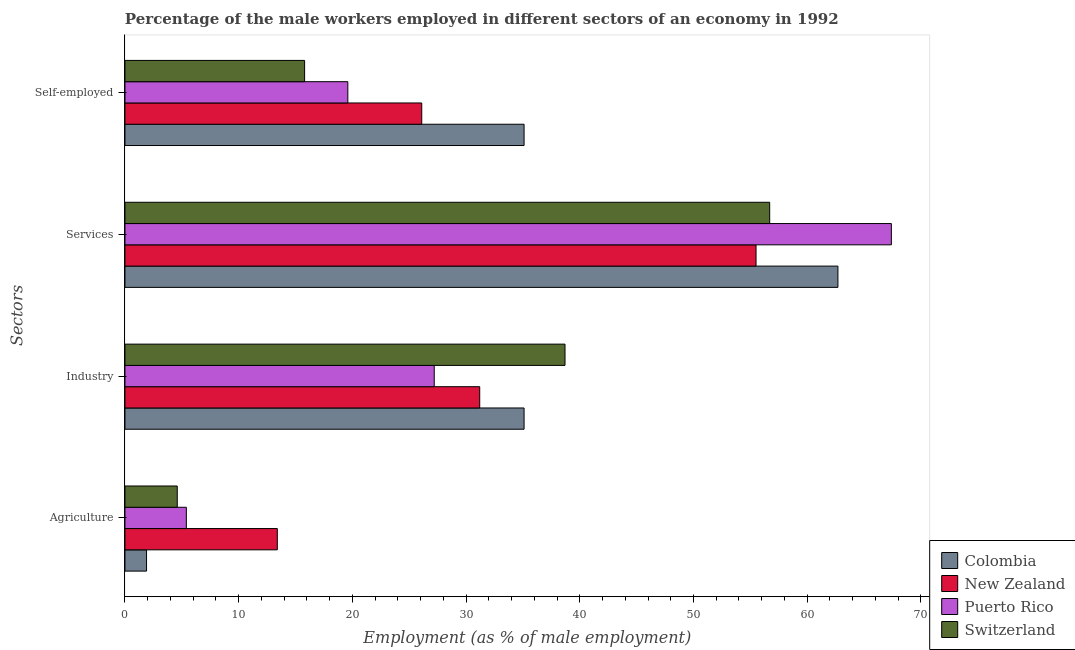How many groups of bars are there?
Give a very brief answer. 4. Are the number of bars per tick equal to the number of legend labels?
Offer a terse response. Yes. Are the number of bars on each tick of the Y-axis equal?
Make the answer very short. Yes. How many bars are there on the 1st tick from the top?
Make the answer very short. 4. How many bars are there on the 1st tick from the bottom?
Keep it short and to the point. 4. What is the label of the 3rd group of bars from the top?
Your response must be concise. Industry. What is the percentage of male workers in industry in Puerto Rico?
Offer a terse response. 27.2. Across all countries, what is the maximum percentage of self employed male workers?
Your answer should be compact. 35.1. Across all countries, what is the minimum percentage of male workers in industry?
Provide a succinct answer. 27.2. In which country was the percentage of self employed male workers maximum?
Make the answer very short. Colombia. In which country was the percentage of male workers in services minimum?
Offer a very short reply. New Zealand. What is the total percentage of male workers in services in the graph?
Give a very brief answer. 242.3. What is the difference between the percentage of male workers in agriculture in Switzerland and that in New Zealand?
Offer a terse response. -8.8. What is the difference between the percentage of male workers in agriculture in New Zealand and the percentage of male workers in services in Colombia?
Offer a very short reply. -49.3. What is the average percentage of male workers in services per country?
Your response must be concise. 60.58. What is the difference between the percentage of male workers in industry and percentage of male workers in services in Colombia?
Your answer should be very brief. -27.6. What is the ratio of the percentage of male workers in industry in Colombia to that in New Zealand?
Give a very brief answer. 1.12. Is the percentage of male workers in agriculture in Switzerland less than that in Puerto Rico?
Provide a succinct answer. Yes. Is the difference between the percentage of male workers in industry in Switzerland and Colombia greater than the difference between the percentage of male workers in agriculture in Switzerland and Colombia?
Offer a terse response. Yes. What is the difference between the highest and the second highest percentage of male workers in industry?
Provide a short and direct response. 3.6. What is the difference between the highest and the lowest percentage of self employed male workers?
Offer a terse response. 19.3. In how many countries, is the percentage of male workers in agriculture greater than the average percentage of male workers in agriculture taken over all countries?
Offer a terse response. 1. Is the sum of the percentage of self employed male workers in Colombia and New Zealand greater than the maximum percentage of male workers in industry across all countries?
Keep it short and to the point. Yes. What does the 1st bar from the top in Agriculture represents?
Offer a terse response. Switzerland. What does the 3rd bar from the bottom in Industry represents?
Provide a succinct answer. Puerto Rico. Is it the case that in every country, the sum of the percentage of male workers in agriculture and percentage of male workers in industry is greater than the percentage of male workers in services?
Ensure brevity in your answer.  No. Are the values on the major ticks of X-axis written in scientific E-notation?
Your answer should be very brief. No. Where does the legend appear in the graph?
Provide a succinct answer. Bottom right. How many legend labels are there?
Make the answer very short. 4. What is the title of the graph?
Provide a succinct answer. Percentage of the male workers employed in different sectors of an economy in 1992. Does "Brunei Darussalam" appear as one of the legend labels in the graph?
Give a very brief answer. No. What is the label or title of the X-axis?
Provide a short and direct response. Employment (as % of male employment). What is the label or title of the Y-axis?
Offer a terse response. Sectors. What is the Employment (as % of male employment) of Colombia in Agriculture?
Keep it short and to the point. 1.9. What is the Employment (as % of male employment) of New Zealand in Agriculture?
Ensure brevity in your answer.  13.4. What is the Employment (as % of male employment) in Puerto Rico in Agriculture?
Provide a succinct answer. 5.4. What is the Employment (as % of male employment) of Switzerland in Agriculture?
Your answer should be very brief. 4.6. What is the Employment (as % of male employment) in Colombia in Industry?
Your response must be concise. 35.1. What is the Employment (as % of male employment) of New Zealand in Industry?
Offer a very short reply. 31.2. What is the Employment (as % of male employment) of Puerto Rico in Industry?
Provide a succinct answer. 27.2. What is the Employment (as % of male employment) of Switzerland in Industry?
Ensure brevity in your answer.  38.7. What is the Employment (as % of male employment) of Colombia in Services?
Your response must be concise. 62.7. What is the Employment (as % of male employment) in New Zealand in Services?
Give a very brief answer. 55.5. What is the Employment (as % of male employment) of Puerto Rico in Services?
Your answer should be compact. 67.4. What is the Employment (as % of male employment) in Switzerland in Services?
Make the answer very short. 56.7. What is the Employment (as % of male employment) in Colombia in Self-employed?
Offer a very short reply. 35.1. What is the Employment (as % of male employment) in New Zealand in Self-employed?
Give a very brief answer. 26.1. What is the Employment (as % of male employment) in Puerto Rico in Self-employed?
Keep it short and to the point. 19.6. What is the Employment (as % of male employment) of Switzerland in Self-employed?
Provide a short and direct response. 15.8. Across all Sectors, what is the maximum Employment (as % of male employment) of Colombia?
Give a very brief answer. 62.7. Across all Sectors, what is the maximum Employment (as % of male employment) in New Zealand?
Keep it short and to the point. 55.5. Across all Sectors, what is the maximum Employment (as % of male employment) of Puerto Rico?
Offer a very short reply. 67.4. Across all Sectors, what is the maximum Employment (as % of male employment) of Switzerland?
Offer a terse response. 56.7. Across all Sectors, what is the minimum Employment (as % of male employment) of Colombia?
Make the answer very short. 1.9. Across all Sectors, what is the minimum Employment (as % of male employment) of New Zealand?
Offer a very short reply. 13.4. Across all Sectors, what is the minimum Employment (as % of male employment) of Puerto Rico?
Keep it short and to the point. 5.4. Across all Sectors, what is the minimum Employment (as % of male employment) of Switzerland?
Your response must be concise. 4.6. What is the total Employment (as % of male employment) of Colombia in the graph?
Ensure brevity in your answer.  134.8. What is the total Employment (as % of male employment) of New Zealand in the graph?
Make the answer very short. 126.2. What is the total Employment (as % of male employment) of Puerto Rico in the graph?
Provide a succinct answer. 119.6. What is the total Employment (as % of male employment) of Switzerland in the graph?
Your answer should be very brief. 115.8. What is the difference between the Employment (as % of male employment) in Colombia in Agriculture and that in Industry?
Your response must be concise. -33.2. What is the difference between the Employment (as % of male employment) of New Zealand in Agriculture and that in Industry?
Keep it short and to the point. -17.8. What is the difference between the Employment (as % of male employment) in Puerto Rico in Agriculture and that in Industry?
Offer a very short reply. -21.8. What is the difference between the Employment (as % of male employment) in Switzerland in Agriculture and that in Industry?
Provide a short and direct response. -34.1. What is the difference between the Employment (as % of male employment) in Colombia in Agriculture and that in Services?
Your response must be concise. -60.8. What is the difference between the Employment (as % of male employment) in New Zealand in Agriculture and that in Services?
Provide a short and direct response. -42.1. What is the difference between the Employment (as % of male employment) in Puerto Rico in Agriculture and that in Services?
Make the answer very short. -62. What is the difference between the Employment (as % of male employment) in Switzerland in Agriculture and that in Services?
Keep it short and to the point. -52.1. What is the difference between the Employment (as % of male employment) of Colombia in Agriculture and that in Self-employed?
Offer a very short reply. -33.2. What is the difference between the Employment (as % of male employment) of Colombia in Industry and that in Services?
Your answer should be compact. -27.6. What is the difference between the Employment (as % of male employment) of New Zealand in Industry and that in Services?
Your answer should be very brief. -24.3. What is the difference between the Employment (as % of male employment) in Puerto Rico in Industry and that in Services?
Your answer should be compact. -40.2. What is the difference between the Employment (as % of male employment) of Switzerland in Industry and that in Services?
Your response must be concise. -18. What is the difference between the Employment (as % of male employment) of Colombia in Industry and that in Self-employed?
Ensure brevity in your answer.  0. What is the difference between the Employment (as % of male employment) of Switzerland in Industry and that in Self-employed?
Provide a short and direct response. 22.9. What is the difference between the Employment (as % of male employment) of Colombia in Services and that in Self-employed?
Your answer should be very brief. 27.6. What is the difference between the Employment (as % of male employment) in New Zealand in Services and that in Self-employed?
Give a very brief answer. 29.4. What is the difference between the Employment (as % of male employment) in Puerto Rico in Services and that in Self-employed?
Give a very brief answer. 47.8. What is the difference between the Employment (as % of male employment) of Switzerland in Services and that in Self-employed?
Your answer should be very brief. 40.9. What is the difference between the Employment (as % of male employment) in Colombia in Agriculture and the Employment (as % of male employment) in New Zealand in Industry?
Keep it short and to the point. -29.3. What is the difference between the Employment (as % of male employment) in Colombia in Agriculture and the Employment (as % of male employment) in Puerto Rico in Industry?
Provide a succinct answer. -25.3. What is the difference between the Employment (as % of male employment) in Colombia in Agriculture and the Employment (as % of male employment) in Switzerland in Industry?
Make the answer very short. -36.8. What is the difference between the Employment (as % of male employment) of New Zealand in Agriculture and the Employment (as % of male employment) of Puerto Rico in Industry?
Your answer should be very brief. -13.8. What is the difference between the Employment (as % of male employment) in New Zealand in Agriculture and the Employment (as % of male employment) in Switzerland in Industry?
Ensure brevity in your answer.  -25.3. What is the difference between the Employment (as % of male employment) in Puerto Rico in Agriculture and the Employment (as % of male employment) in Switzerland in Industry?
Make the answer very short. -33.3. What is the difference between the Employment (as % of male employment) in Colombia in Agriculture and the Employment (as % of male employment) in New Zealand in Services?
Provide a short and direct response. -53.6. What is the difference between the Employment (as % of male employment) of Colombia in Agriculture and the Employment (as % of male employment) of Puerto Rico in Services?
Make the answer very short. -65.5. What is the difference between the Employment (as % of male employment) in Colombia in Agriculture and the Employment (as % of male employment) in Switzerland in Services?
Your answer should be compact. -54.8. What is the difference between the Employment (as % of male employment) of New Zealand in Agriculture and the Employment (as % of male employment) of Puerto Rico in Services?
Provide a succinct answer. -54. What is the difference between the Employment (as % of male employment) of New Zealand in Agriculture and the Employment (as % of male employment) of Switzerland in Services?
Provide a succinct answer. -43.3. What is the difference between the Employment (as % of male employment) of Puerto Rico in Agriculture and the Employment (as % of male employment) of Switzerland in Services?
Offer a terse response. -51.3. What is the difference between the Employment (as % of male employment) of Colombia in Agriculture and the Employment (as % of male employment) of New Zealand in Self-employed?
Provide a short and direct response. -24.2. What is the difference between the Employment (as % of male employment) of Colombia in Agriculture and the Employment (as % of male employment) of Puerto Rico in Self-employed?
Provide a short and direct response. -17.7. What is the difference between the Employment (as % of male employment) in Colombia in Agriculture and the Employment (as % of male employment) in Switzerland in Self-employed?
Your response must be concise. -13.9. What is the difference between the Employment (as % of male employment) of Puerto Rico in Agriculture and the Employment (as % of male employment) of Switzerland in Self-employed?
Keep it short and to the point. -10.4. What is the difference between the Employment (as % of male employment) of Colombia in Industry and the Employment (as % of male employment) of New Zealand in Services?
Provide a short and direct response. -20.4. What is the difference between the Employment (as % of male employment) of Colombia in Industry and the Employment (as % of male employment) of Puerto Rico in Services?
Provide a short and direct response. -32.3. What is the difference between the Employment (as % of male employment) of Colombia in Industry and the Employment (as % of male employment) of Switzerland in Services?
Offer a terse response. -21.6. What is the difference between the Employment (as % of male employment) of New Zealand in Industry and the Employment (as % of male employment) of Puerto Rico in Services?
Ensure brevity in your answer.  -36.2. What is the difference between the Employment (as % of male employment) in New Zealand in Industry and the Employment (as % of male employment) in Switzerland in Services?
Offer a very short reply. -25.5. What is the difference between the Employment (as % of male employment) of Puerto Rico in Industry and the Employment (as % of male employment) of Switzerland in Services?
Keep it short and to the point. -29.5. What is the difference between the Employment (as % of male employment) of Colombia in Industry and the Employment (as % of male employment) of New Zealand in Self-employed?
Make the answer very short. 9. What is the difference between the Employment (as % of male employment) in Colombia in Industry and the Employment (as % of male employment) in Switzerland in Self-employed?
Keep it short and to the point. 19.3. What is the difference between the Employment (as % of male employment) in New Zealand in Industry and the Employment (as % of male employment) in Switzerland in Self-employed?
Your response must be concise. 15.4. What is the difference between the Employment (as % of male employment) in Puerto Rico in Industry and the Employment (as % of male employment) in Switzerland in Self-employed?
Keep it short and to the point. 11.4. What is the difference between the Employment (as % of male employment) in Colombia in Services and the Employment (as % of male employment) in New Zealand in Self-employed?
Your answer should be compact. 36.6. What is the difference between the Employment (as % of male employment) of Colombia in Services and the Employment (as % of male employment) of Puerto Rico in Self-employed?
Provide a short and direct response. 43.1. What is the difference between the Employment (as % of male employment) in Colombia in Services and the Employment (as % of male employment) in Switzerland in Self-employed?
Make the answer very short. 46.9. What is the difference between the Employment (as % of male employment) in New Zealand in Services and the Employment (as % of male employment) in Puerto Rico in Self-employed?
Make the answer very short. 35.9. What is the difference between the Employment (as % of male employment) in New Zealand in Services and the Employment (as % of male employment) in Switzerland in Self-employed?
Provide a succinct answer. 39.7. What is the difference between the Employment (as % of male employment) of Puerto Rico in Services and the Employment (as % of male employment) of Switzerland in Self-employed?
Offer a very short reply. 51.6. What is the average Employment (as % of male employment) in Colombia per Sectors?
Offer a terse response. 33.7. What is the average Employment (as % of male employment) of New Zealand per Sectors?
Make the answer very short. 31.55. What is the average Employment (as % of male employment) of Puerto Rico per Sectors?
Your response must be concise. 29.9. What is the average Employment (as % of male employment) of Switzerland per Sectors?
Ensure brevity in your answer.  28.95. What is the difference between the Employment (as % of male employment) in New Zealand and Employment (as % of male employment) in Puerto Rico in Agriculture?
Ensure brevity in your answer.  8. What is the difference between the Employment (as % of male employment) of Puerto Rico and Employment (as % of male employment) of Switzerland in Agriculture?
Provide a succinct answer. 0.8. What is the difference between the Employment (as % of male employment) of Colombia and Employment (as % of male employment) of New Zealand in Industry?
Provide a short and direct response. 3.9. What is the difference between the Employment (as % of male employment) of New Zealand and Employment (as % of male employment) of Puerto Rico in Industry?
Offer a very short reply. 4. What is the difference between the Employment (as % of male employment) in Colombia and Employment (as % of male employment) in New Zealand in Services?
Make the answer very short. 7.2. What is the difference between the Employment (as % of male employment) of New Zealand and Employment (as % of male employment) of Switzerland in Services?
Give a very brief answer. -1.2. What is the difference between the Employment (as % of male employment) of Colombia and Employment (as % of male employment) of New Zealand in Self-employed?
Offer a very short reply. 9. What is the difference between the Employment (as % of male employment) of Colombia and Employment (as % of male employment) of Switzerland in Self-employed?
Offer a very short reply. 19.3. What is the difference between the Employment (as % of male employment) in New Zealand and Employment (as % of male employment) in Puerto Rico in Self-employed?
Make the answer very short. 6.5. What is the difference between the Employment (as % of male employment) in Puerto Rico and Employment (as % of male employment) in Switzerland in Self-employed?
Your answer should be compact. 3.8. What is the ratio of the Employment (as % of male employment) of Colombia in Agriculture to that in Industry?
Offer a terse response. 0.05. What is the ratio of the Employment (as % of male employment) of New Zealand in Agriculture to that in Industry?
Your answer should be very brief. 0.43. What is the ratio of the Employment (as % of male employment) of Puerto Rico in Agriculture to that in Industry?
Your response must be concise. 0.2. What is the ratio of the Employment (as % of male employment) of Switzerland in Agriculture to that in Industry?
Your answer should be very brief. 0.12. What is the ratio of the Employment (as % of male employment) in Colombia in Agriculture to that in Services?
Make the answer very short. 0.03. What is the ratio of the Employment (as % of male employment) in New Zealand in Agriculture to that in Services?
Your response must be concise. 0.24. What is the ratio of the Employment (as % of male employment) in Puerto Rico in Agriculture to that in Services?
Give a very brief answer. 0.08. What is the ratio of the Employment (as % of male employment) of Switzerland in Agriculture to that in Services?
Your response must be concise. 0.08. What is the ratio of the Employment (as % of male employment) of Colombia in Agriculture to that in Self-employed?
Your response must be concise. 0.05. What is the ratio of the Employment (as % of male employment) in New Zealand in Agriculture to that in Self-employed?
Make the answer very short. 0.51. What is the ratio of the Employment (as % of male employment) of Puerto Rico in Agriculture to that in Self-employed?
Your response must be concise. 0.28. What is the ratio of the Employment (as % of male employment) of Switzerland in Agriculture to that in Self-employed?
Provide a succinct answer. 0.29. What is the ratio of the Employment (as % of male employment) of Colombia in Industry to that in Services?
Your answer should be very brief. 0.56. What is the ratio of the Employment (as % of male employment) in New Zealand in Industry to that in Services?
Your answer should be compact. 0.56. What is the ratio of the Employment (as % of male employment) in Puerto Rico in Industry to that in Services?
Provide a short and direct response. 0.4. What is the ratio of the Employment (as % of male employment) of Switzerland in Industry to that in Services?
Offer a very short reply. 0.68. What is the ratio of the Employment (as % of male employment) in New Zealand in Industry to that in Self-employed?
Provide a succinct answer. 1.2. What is the ratio of the Employment (as % of male employment) in Puerto Rico in Industry to that in Self-employed?
Offer a very short reply. 1.39. What is the ratio of the Employment (as % of male employment) in Switzerland in Industry to that in Self-employed?
Your answer should be very brief. 2.45. What is the ratio of the Employment (as % of male employment) of Colombia in Services to that in Self-employed?
Keep it short and to the point. 1.79. What is the ratio of the Employment (as % of male employment) in New Zealand in Services to that in Self-employed?
Offer a terse response. 2.13. What is the ratio of the Employment (as % of male employment) of Puerto Rico in Services to that in Self-employed?
Your answer should be compact. 3.44. What is the ratio of the Employment (as % of male employment) in Switzerland in Services to that in Self-employed?
Make the answer very short. 3.59. What is the difference between the highest and the second highest Employment (as % of male employment) in Colombia?
Offer a very short reply. 27.6. What is the difference between the highest and the second highest Employment (as % of male employment) of New Zealand?
Ensure brevity in your answer.  24.3. What is the difference between the highest and the second highest Employment (as % of male employment) in Puerto Rico?
Keep it short and to the point. 40.2. What is the difference between the highest and the second highest Employment (as % of male employment) in Switzerland?
Your answer should be very brief. 18. What is the difference between the highest and the lowest Employment (as % of male employment) in Colombia?
Your response must be concise. 60.8. What is the difference between the highest and the lowest Employment (as % of male employment) in New Zealand?
Provide a succinct answer. 42.1. What is the difference between the highest and the lowest Employment (as % of male employment) in Switzerland?
Your answer should be very brief. 52.1. 